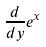Convert formula to latex. <formula><loc_0><loc_0><loc_500><loc_500>\frac { d } { d y } e ^ { x }</formula> 